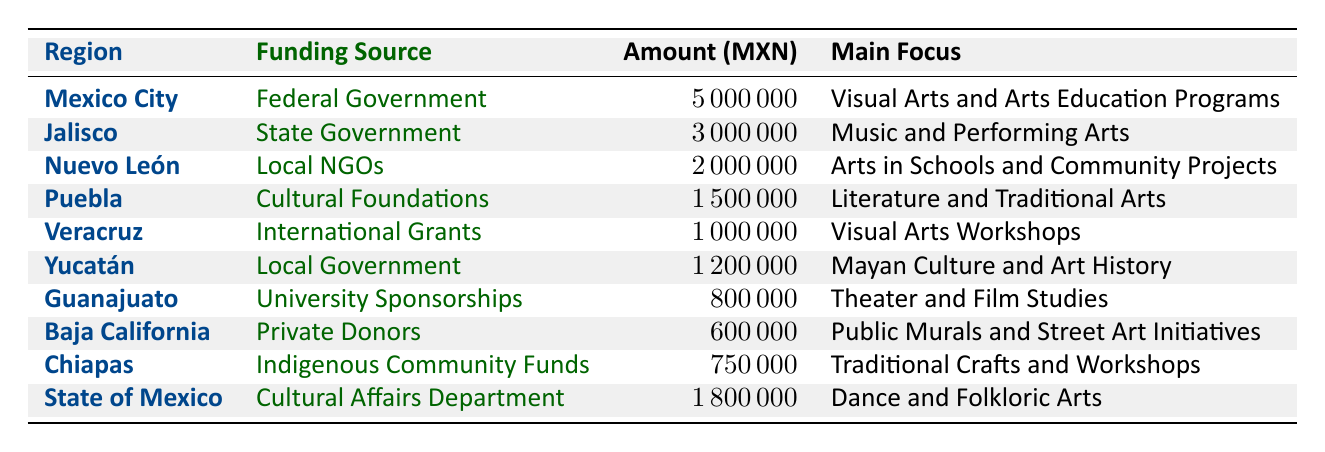What is the total amount of funding allocated for art education in Mexico City? The table shows that the funding amount for Mexico City is five million Mexican pesos. Therefore, the total amount allocated there is five million.
Answer: 5000000 What is the main focus of art education funding in Jalisco? According to the table, the main focus of the funding in Jalisco is Music and Performing Arts. This is directly listed in the main focus column next to the Jalisco entry.
Answer: Music and Performing Arts Which region received the least amount of funding for art education in 2022? By comparing the amounts listed in the table, Baja California received 600,000 pesos, which is the lowest amount among all regions. This is confirmed by examining all the funding amounts presented.
Answer: Baja California Is the funding for art education in Veracruz provided by the federal government? Looking at the table, the funding in Veracruz is provided by International Grants, not the federal government. Therefore, the statement is false.
Answer: No How much more funding did the State of Mexico receive compared to Guanajuato? The State of Mexico received 1,800,000 pesos, while Guanajuato received 800,000 pesos. The difference between these amounts is 1,800,000 - 800,000 = 1,000,000 pesos. Thus, the State of Mexico received one million more.
Answer: 1000000 What is the combined total funding for art education from Federal Government and Local Government sources? The Federal Government allocated 5,000,000 pesos (Mexico City) and the Local Government allocated 1,200,000 pesos (Yucatán). Adding these amounts together gives us 5,000,000 + 1,200,000 = 6,200,000 pesos. This sums up the total from both sources.
Answer: 6200000 Does the amount allocated for arts in schools and community projects exceed the funding for theater and film studies? The funding for Arts in Schools and Community Projects, provided by Local NGOs, is 2,000,000 pesos, while the funding for Theater and Film Studies in Guanajuato is 800,000 pesos. Since 2,000,000 is greater than 800,000, the statement is true.
Answer: Yes What percentage of the total funding reported in the table is allocated to Puebla? The total funding across all regions is 12,000,000 pesos (5,000,000 + 3,000,000 + 2,000,000 + 1,500,000 + 1,000,000 + 1,200,000 + 800,000 + 600,000 + 750,000 + 1,800,000). Puebla's funding of 1,500,000 pesos represents (1,500,000 / 12,000,000) * 100 = 12.5 percent of the total. Therefore, Puebla receives 12.5 percent of the total funding.
Answer: 12.5% Which regions focused on visual arts in their funding? The regions focusing on visual arts are Mexico City, which emphasizes Visual Arts and Arts Education Programs, and Veracruz, which supports Visual Arts Workshops. Both entries clearly indicate a focus on visual arts.
Answer: Mexico City, Veracruz 